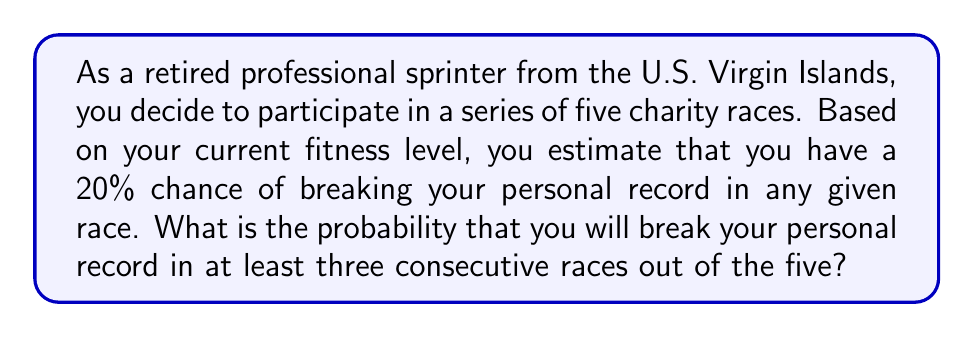Show me your answer to this math problem. Let's approach this step-by-step:

1) First, we need to identify the possible ways to break personal records in at least three consecutive races out of five:
   - Races 1, 2, 3
   - Races 2, 3, 4
   - Races 3, 4, 5
   - Races 1, 2, 3, 4
   - Races 2, 3, 4, 5
   - All five races

2) Let's define the events:
   $p$ = probability of breaking personal record in a single race = 0.20
   $q$ = probability of not breaking personal record in a single race = 1 - p = 0.80

3) Now, let's calculate the probability for each scenario:

   a) For exactly 3 consecutive races:
      $P(\text{3 consecutive}) = p^3q^2 \cdot 3$ (3 ways to choose 3 consecutive races)
      $= (0.20)^3(0.80)^2 \cdot 3 = 0.00768 \cdot 3 = 0.02304$

   b) For exactly 4 consecutive races:
      $P(\text{4 consecutive}) = p^4q \cdot 2$ (2 ways to choose 4 consecutive races)
      $= (0.20)^4(0.80) \cdot 2 = 0.000512 \cdot 2 = 0.001024$

   c) For all 5 races:
      $P(\text{5 consecutive}) = p^5 = (0.20)^5 = 0.00003125$

4) The total probability is the sum of these individual probabilities:

   $P(\text{at least 3 consecutive}) = P(\text{3 consecutive}) + P(\text{4 consecutive}) + P(\text{5 consecutive})$
   $= 0.02304 + 0.001024 + 0.00003125$
   $= 0.02409525$

5) Converting to a percentage:
   $0.02409525 \cdot 100\% = 2.41\%$ (rounded to two decimal places)
Answer: The probability of breaking your personal record in at least three consecutive races out of the five is approximately $2.41\%$. 